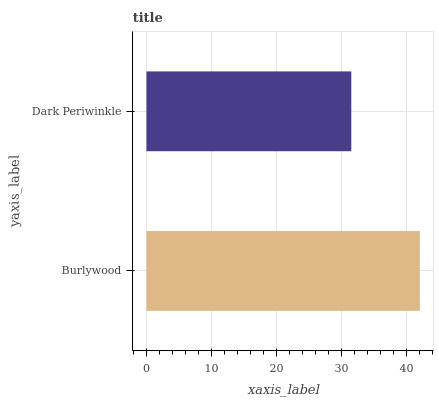Is Dark Periwinkle the minimum?
Answer yes or no. Yes. Is Burlywood the maximum?
Answer yes or no. Yes. Is Dark Periwinkle the maximum?
Answer yes or no. No. Is Burlywood greater than Dark Periwinkle?
Answer yes or no. Yes. Is Dark Periwinkle less than Burlywood?
Answer yes or no. Yes. Is Dark Periwinkle greater than Burlywood?
Answer yes or no. No. Is Burlywood less than Dark Periwinkle?
Answer yes or no. No. Is Burlywood the high median?
Answer yes or no. Yes. Is Dark Periwinkle the low median?
Answer yes or no. Yes. Is Dark Periwinkle the high median?
Answer yes or no. No. Is Burlywood the low median?
Answer yes or no. No. 